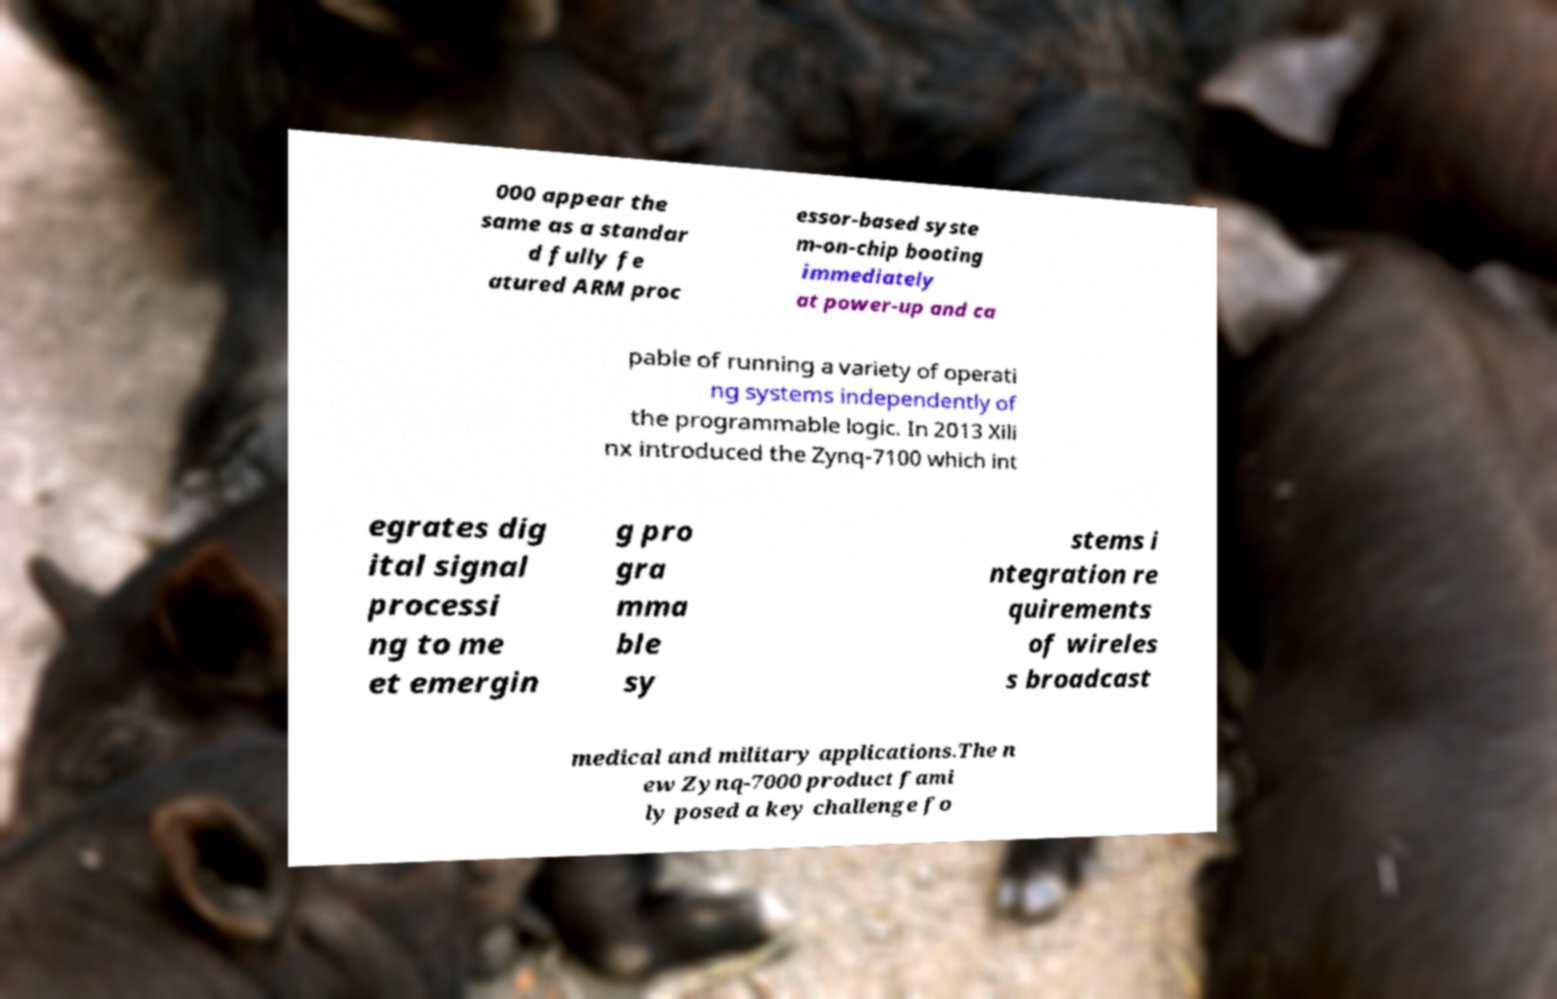Please identify and transcribe the text found in this image. 000 appear the same as a standar d fully fe atured ARM proc essor-based syste m-on-chip booting immediately at power-up and ca pable of running a variety of operati ng systems independently of the programmable logic. In 2013 Xili nx introduced the Zynq-7100 which int egrates dig ital signal processi ng to me et emergin g pro gra mma ble sy stems i ntegration re quirements of wireles s broadcast medical and military applications.The n ew Zynq-7000 product fami ly posed a key challenge fo 